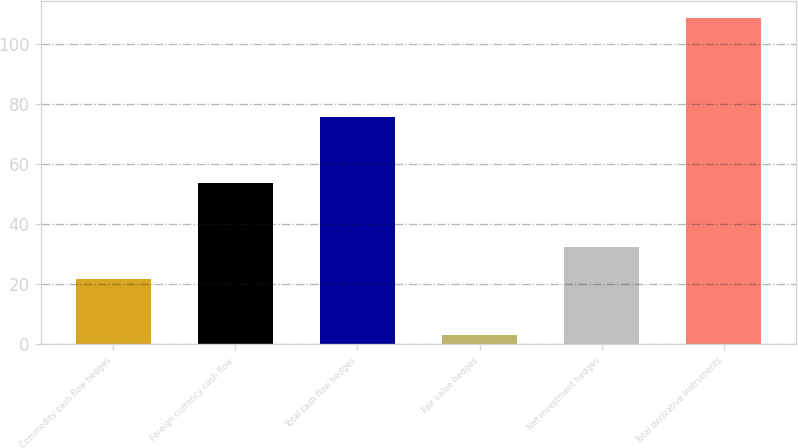Convert chart to OTSL. <chart><loc_0><loc_0><loc_500><loc_500><bar_chart><fcel>Commodity cash flow hedges<fcel>Foreign currency cash flow<fcel>Total cash flow hedges<fcel>Fair value hedges<fcel>Net investment hedges<fcel>Total derivative instruments<nl><fcel>21.8<fcel>53.8<fcel>75.6<fcel>3<fcel>32.36<fcel>108.6<nl></chart> 